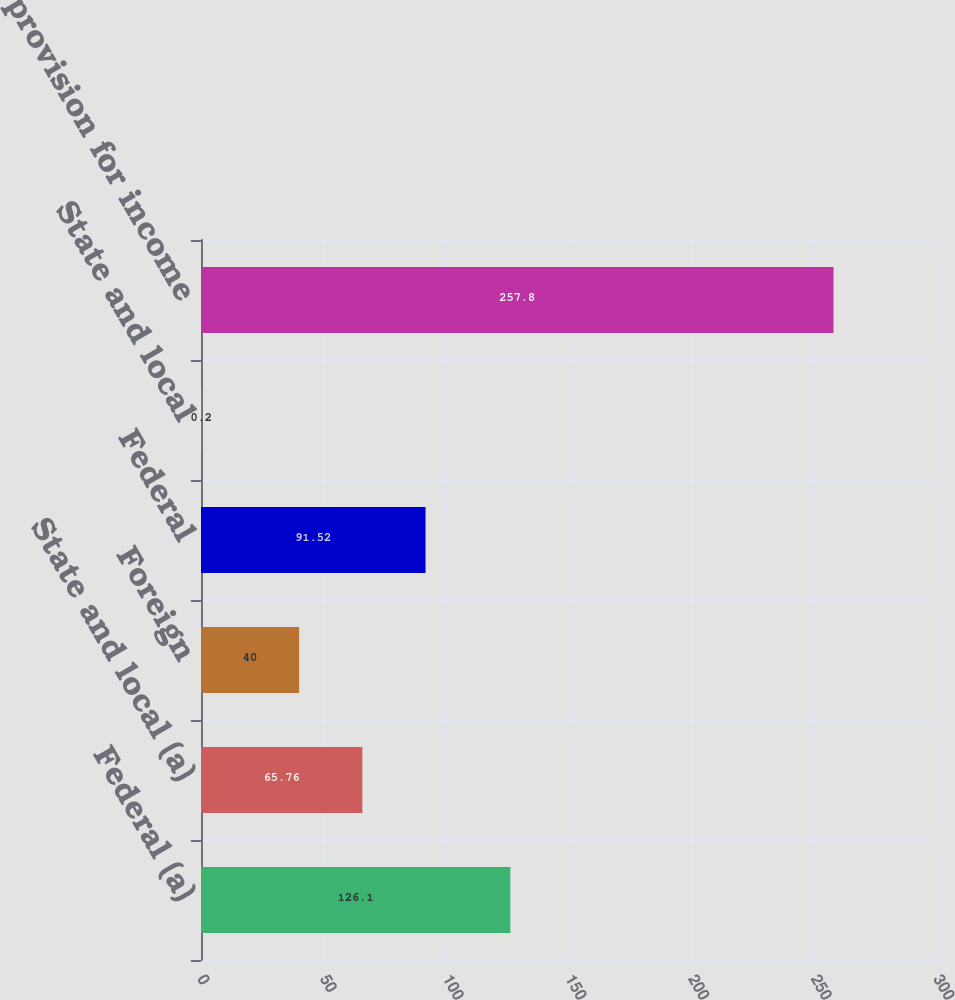<chart> <loc_0><loc_0><loc_500><loc_500><bar_chart><fcel>Federal (a)<fcel>State and local (a)<fcel>Foreign<fcel>Federal<fcel>State and local<fcel>Total provision for income<nl><fcel>126.1<fcel>65.76<fcel>40<fcel>91.52<fcel>0.2<fcel>257.8<nl></chart> 